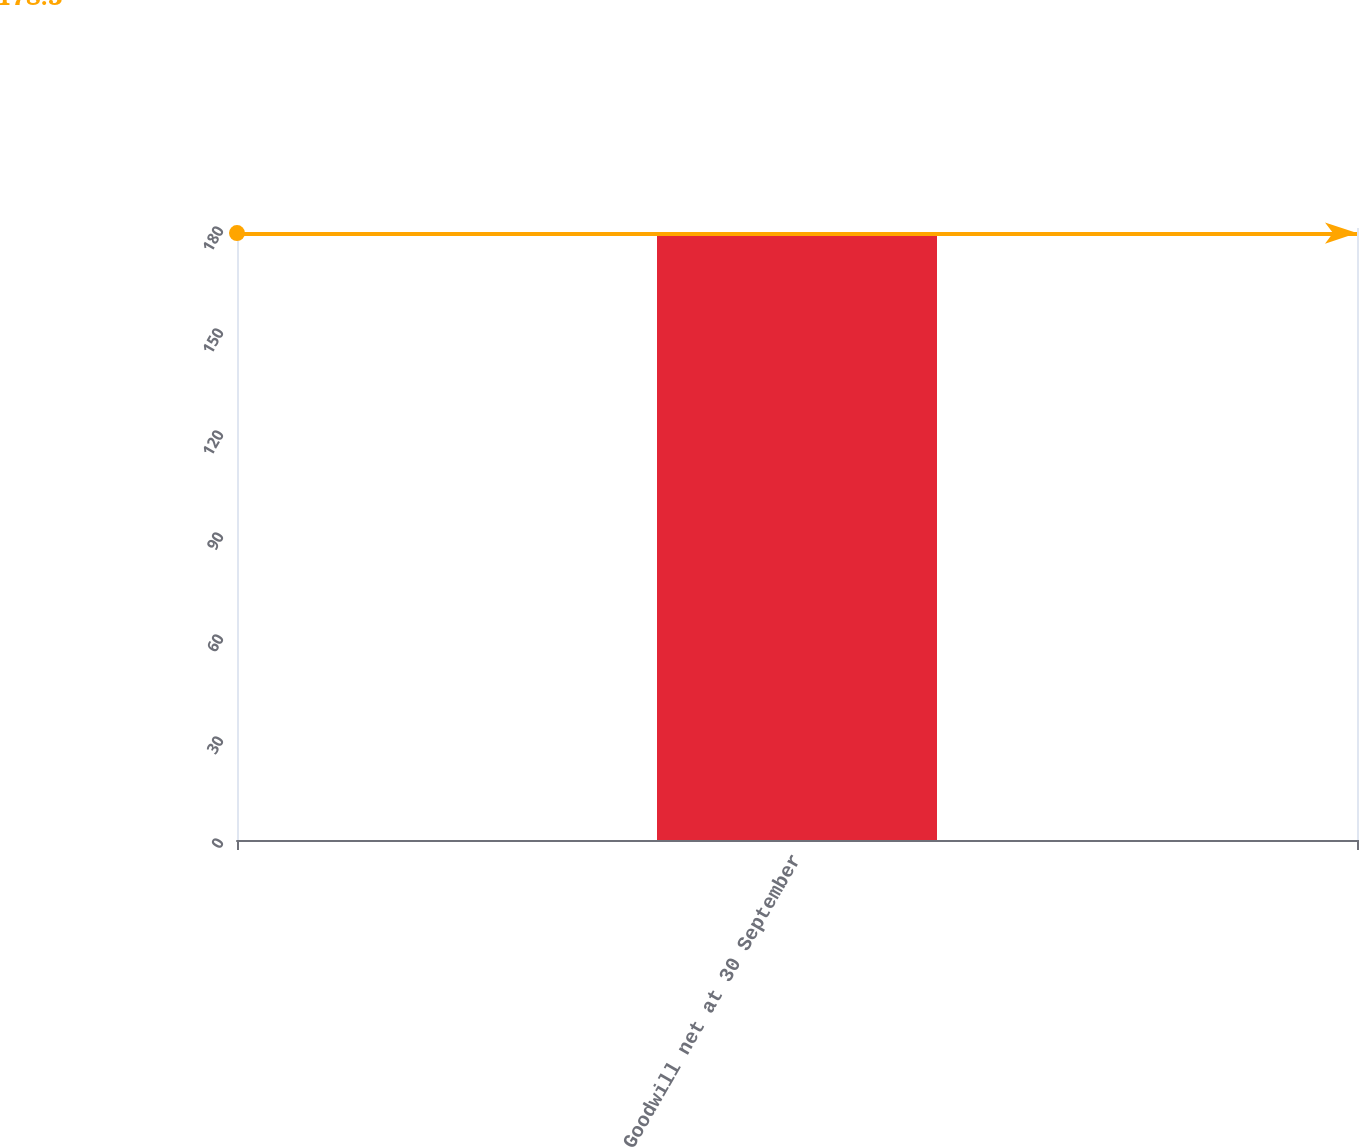Convert chart. <chart><loc_0><loc_0><loc_500><loc_500><bar_chart><fcel>Goodwill net at 30 September<nl><fcel>178.5<nl></chart> 